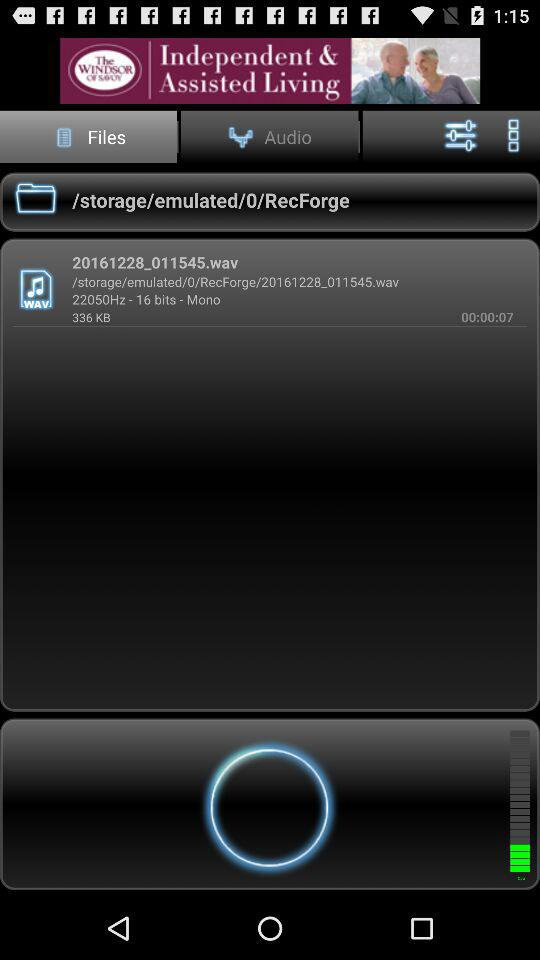How much is the frequency of the audio file? The frequency of the audio file is 22050 Hz. 